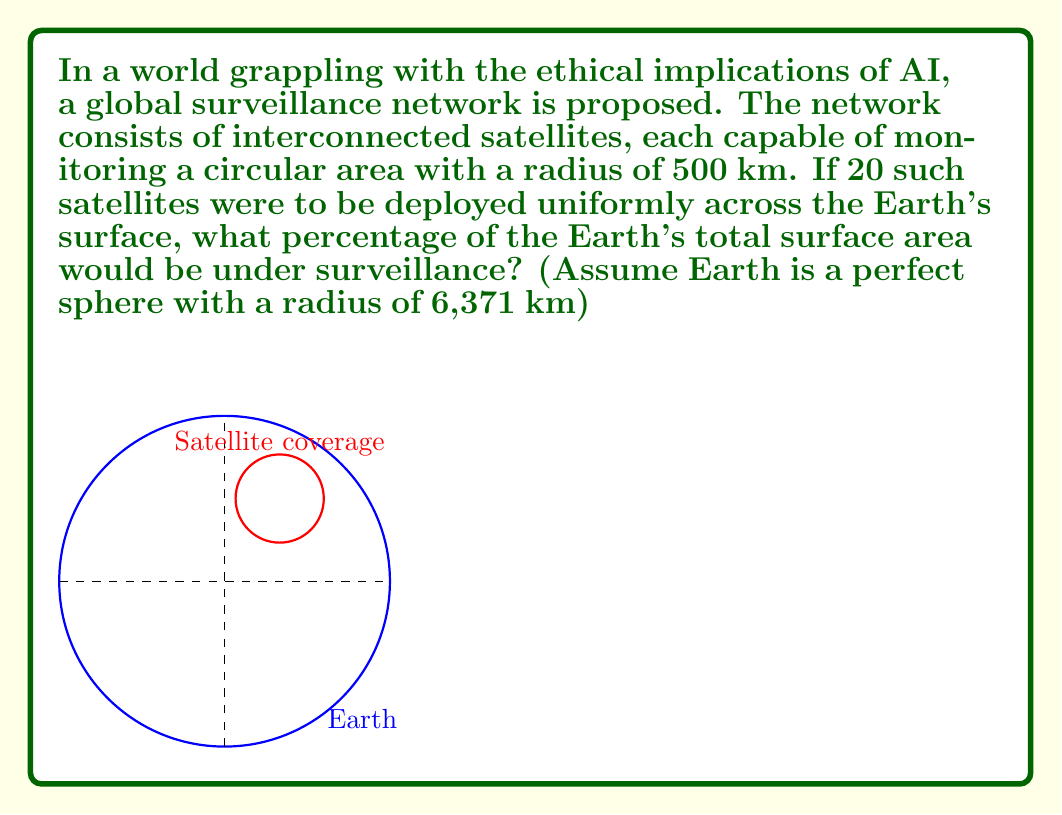Give your solution to this math problem. Let's approach this step-by-step:

1) First, we need to calculate the area that each satellite can monitor:
   Area of one satellite's coverage = $\pi r^2$
   $$ A_{satellite} = \pi (500)^2 = 785,398.16 \text{ km}^2 $$

2) Now, let's calculate the total area covered by all 20 satellites:
   $$ A_{total} = 20 \times 785,398.16 = 15,707,963.2 \text{ km}^2 $$

3) Next, we need to calculate the surface area of the Earth:
   Surface area of a sphere = $4\pi R^2$
   $$ A_{Earth} = 4\pi (6,371)^2 = 510,064,471.9 \text{ km}^2 $$

4) To find the percentage of Earth's surface under surveillance, we divide the total area covered by the satellites by the Earth's surface area and multiply by 100:

   $$ \text{Percentage} = \frac{A_{total}}{A_{Earth}} \times 100 $$
   
   $$ = \frac{15,707,963.2}{510,064,471.9} \times 100 = 3.08\% $$

This result shows that even with advanced technology, the vastness of our planet makes complete surveillance a challenging task, which might provide some comfort to those concerned about privacy in an AI-dominated future.
Answer: 3.08% 